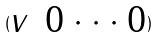<formula> <loc_0><loc_0><loc_500><loc_500>( \begin{matrix} v & 0 \cdot \cdot \cdot 0 \end{matrix} )</formula> 